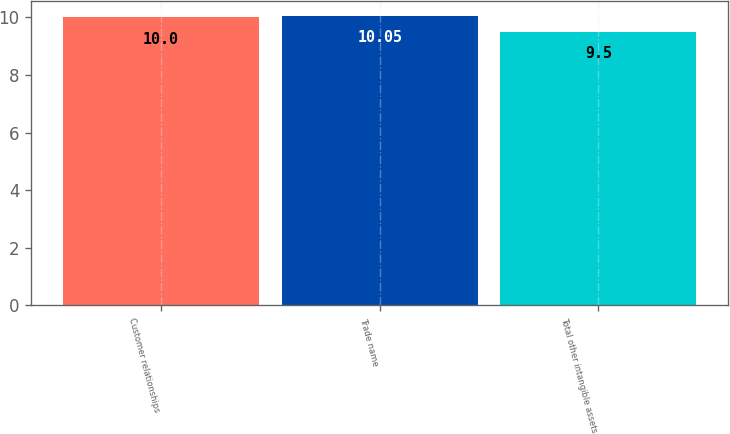Convert chart. <chart><loc_0><loc_0><loc_500><loc_500><bar_chart><fcel>Customer relationships<fcel>Trade name<fcel>Total other intangible assets<nl><fcel>10<fcel>10.05<fcel>9.5<nl></chart> 